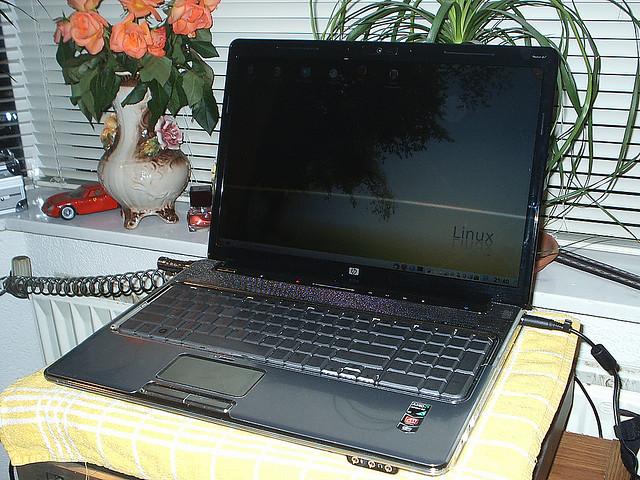What electronic is shown in this picture?
Short answer required. Laptop. What operating system is this computer using?
Answer briefly. Linux. What color is the vase in the back?
Short answer required. White. 